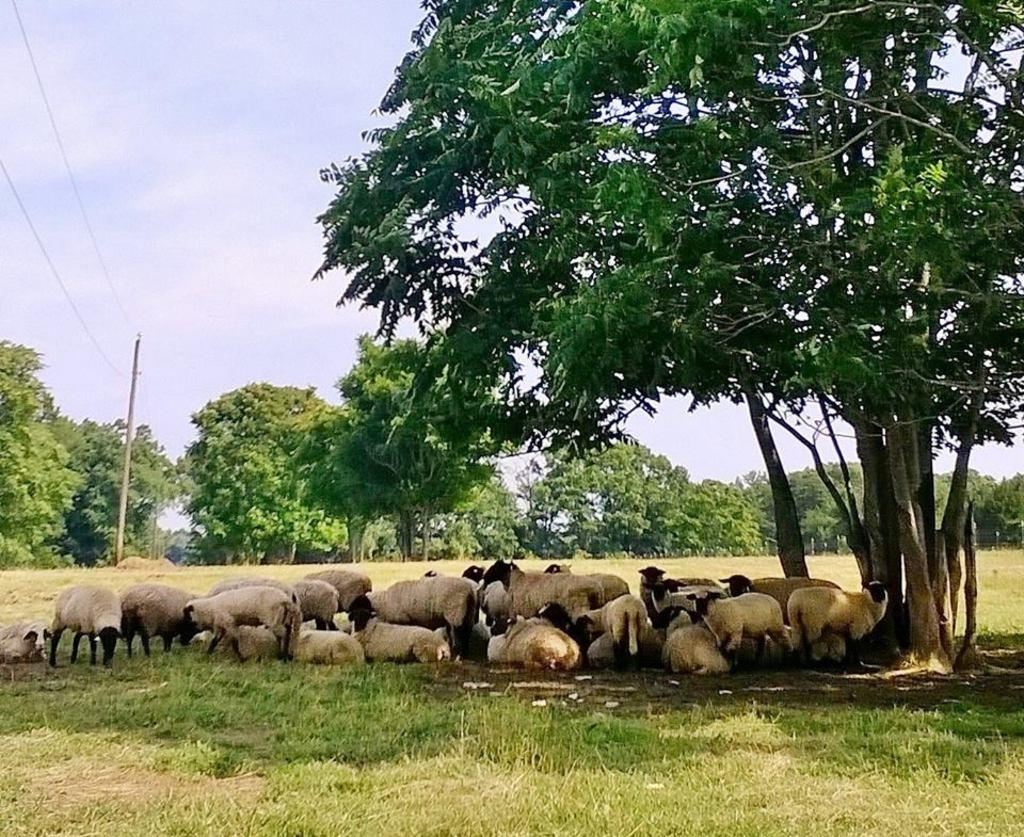What is the main subject of the image? There is a group of sheep in the center of the image. What type of vegetation is visible at the bottom of the image? There is grass at the bottom of the image. What can be seen in the background of the image? There are trees, poles, and wires in the background of the image. How many toads are sitting on the sheep in the image? There are no toads present in the image; it features a group of sheep. What type of yoke is being used by the sheep in the image? Sheep do not use yokes, so this question cannot be answered based on the image. 